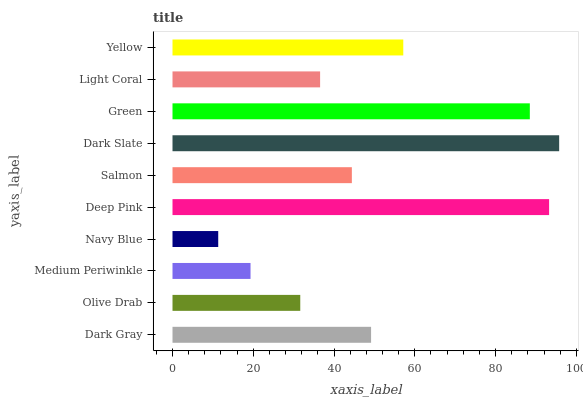Is Navy Blue the minimum?
Answer yes or no. Yes. Is Dark Slate the maximum?
Answer yes or no. Yes. Is Olive Drab the minimum?
Answer yes or no. No. Is Olive Drab the maximum?
Answer yes or no. No. Is Dark Gray greater than Olive Drab?
Answer yes or no. Yes. Is Olive Drab less than Dark Gray?
Answer yes or no. Yes. Is Olive Drab greater than Dark Gray?
Answer yes or no. No. Is Dark Gray less than Olive Drab?
Answer yes or no. No. Is Dark Gray the high median?
Answer yes or no. Yes. Is Salmon the low median?
Answer yes or no. Yes. Is Navy Blue the high median?
Answer yes or no. No. Is Dark Gray the low median?
Answer yes or no. No. 